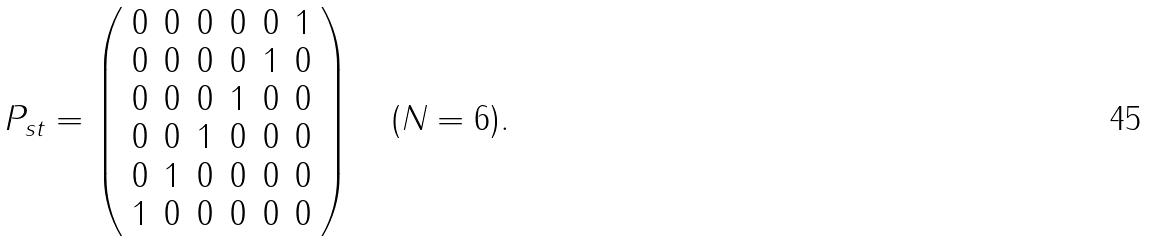<formula> <loc_0><loc_0><loc_500><loc_500>P _ { s t } = \left ( \begin{array} { c c c c c c } 0 & 0 & 0 & 0 & 0 & 1 \\ 0 & 0 & 0 & 0 & 1 & 0 \\ 0 & 0 & 0 & 1 & 0 & 0 \\ 0 & 0 & 1 & 0 & 0 & 0 \\ 0 & 1 & 0 & 0 & 0 & 0 \\ 1 & 0 & 0 & 0 & 0 & 0 \end{array} \right ) \quad ( N = 6 ) . \\</formula> 